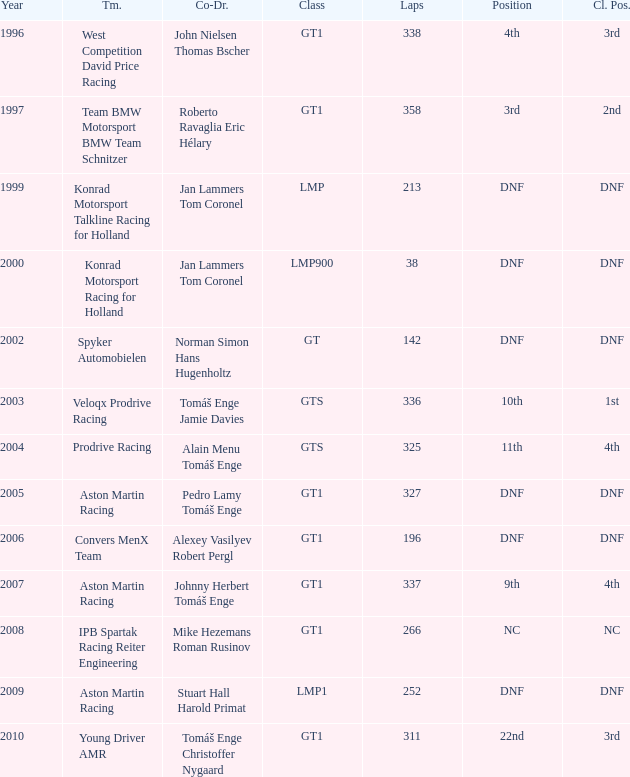Help me parse the entirety of this table. {'header': ['Year', 'Tm.', 'Co-Dr.', 'Class', 'Laps', 'Position', 'Cl. Pos.'], 'rows': [['1996', 'West Competition David Price Racing', 'John Nielsen Thomas Bscher', 'GT1', '338', '4th', '3rd'], ['1997', 'Team BMW Motorsport BMW Team Schnitzer', 'Roberto Ravaglia Eric Hélary', 'GT1', '358', '3rd', '2nd'], ['1999', 'Konrad Motorsport Talkline Racing for Holland', 'Jan Lammers Tom Coronel', 'LMP', '213', 'DNF', 'DNF'], ['2000', 'Konrad Motorsport Racing for Holland', 'Jan Lammers Tom Coronel', 'LMP900', '38', 'DNF', 'DNF'], ['2002', 'Spyker Automobielen', 'Norman Simon Hans Hugenholtz', 'GT', '142', 'DNF', 'DNF'], ['2003', 'Veloqx Prodrive Racing', 'Tomáš Enge Jamie Davies', 'GTS', '336', '10th', '1st'], ['2004', 'Prodrive Racing', 'Alain Menu Tomáš Enge', 'GTS', '325', '11th', '4th'], ['2005', 'Aston Martin Racing', 'Pedro Lamy Tomáš Enge', 'GT1', '327', 'DNF', 'DNF'], ['2006', 'Convers MenX Team', 'Alexey Vasilyev Robert Pergl', 'GT1', '196', 'DNF', 'DNF'], ['2007', 'Aston Martin Racing', 'Johnny Herbert Tomáš Enge', 'GT1', '337', '9th', '4th'], ['2008', 'IPB Spartak Racing Reiter Engineering', 'Mike Hezemans Roman Rusinov', 'GT1', '266', 'NC', 'NC'], ['2009', 'Aston Martin Racing', 'Stuart Hall Harold Primat', 'LMP1', '252', 'DNF', 'DNF'], ['2010', 'Young Driver AMR', 'Tomáš Enge Christoffer Nygaard', 'GT1', '311', '22nd', '3rd']]} What was the position in 1997? 3rd. 